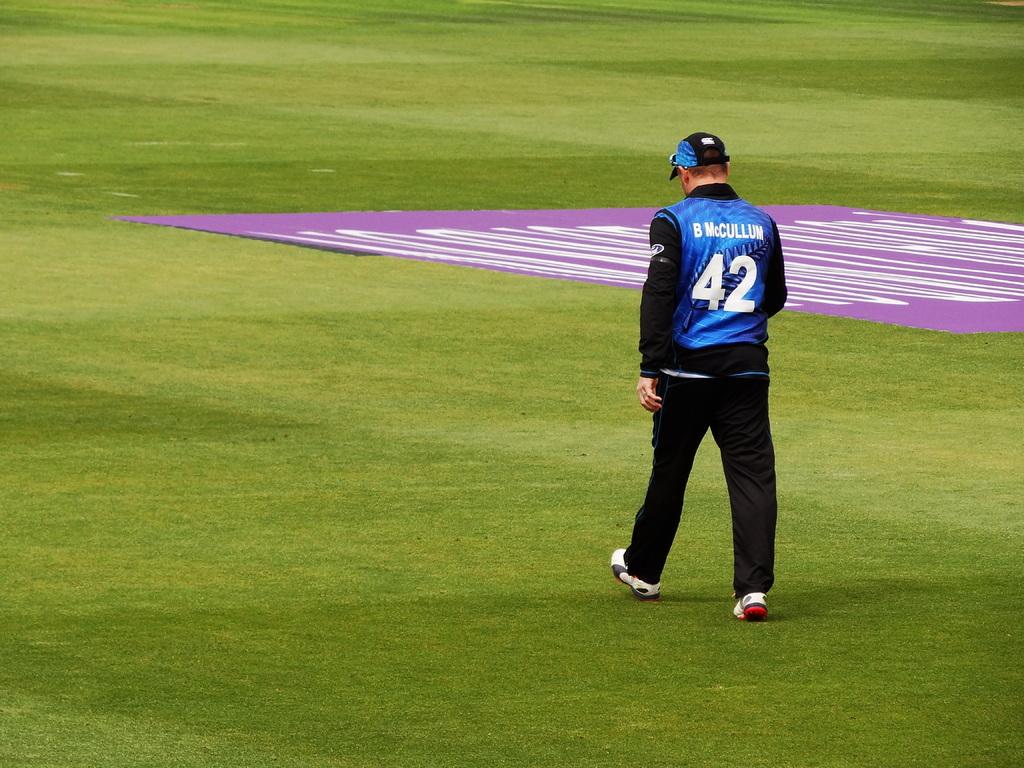What is the guy's number?
Your answer should be compact. 42. What is his last name on his shirt?
Ensure brevity in your answer.  Mccullum. 